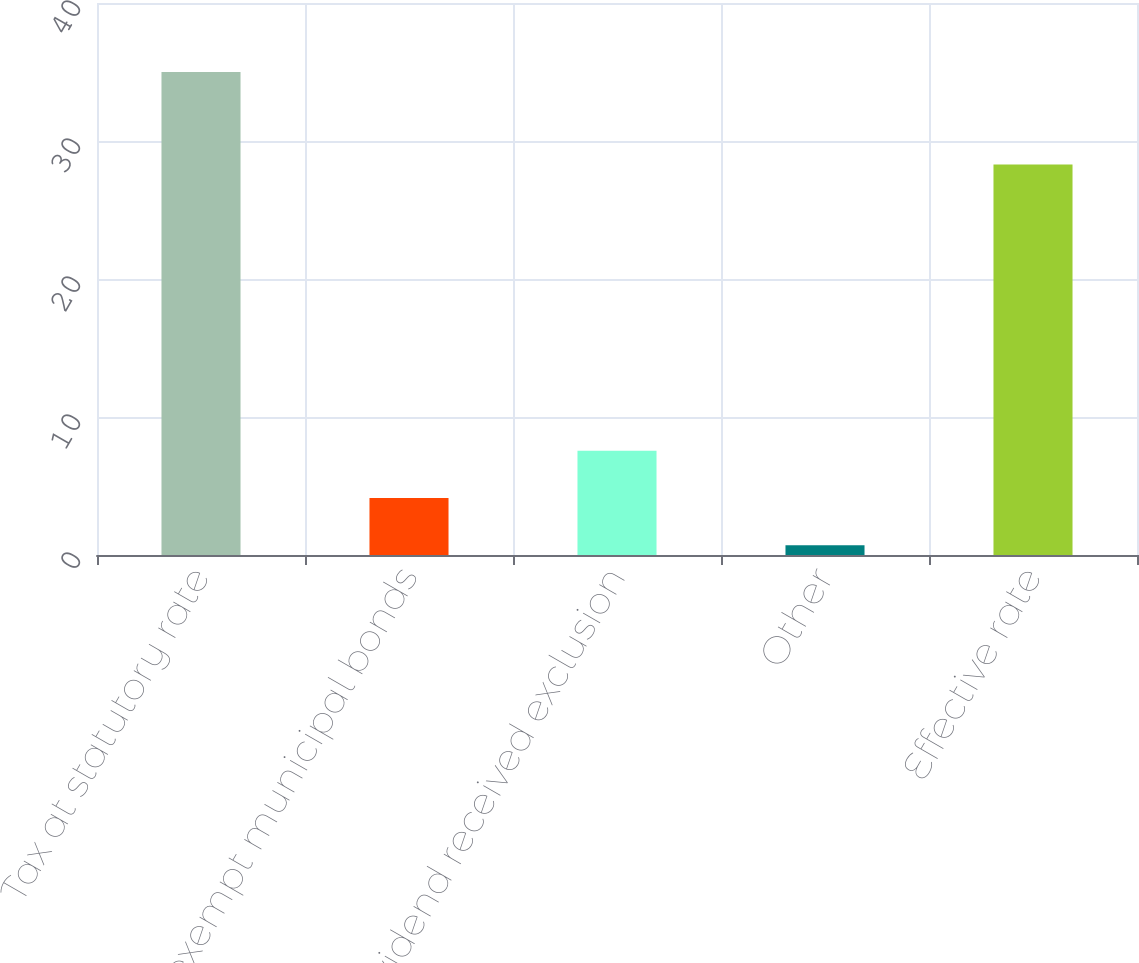<chart> <loc_0><loc_0><loc_500><loc_500><bar_chart><fcel>Tax at statutory rate<fcel>Tax-exempt municipal bonds<fcel>Dividend received exclusion<fcel>Other<fcel>Effective rate<nl><fcel>35<fcel>4.13<fcel>7.56<fcel>0.7<fcel>28.3<nl></chart> 